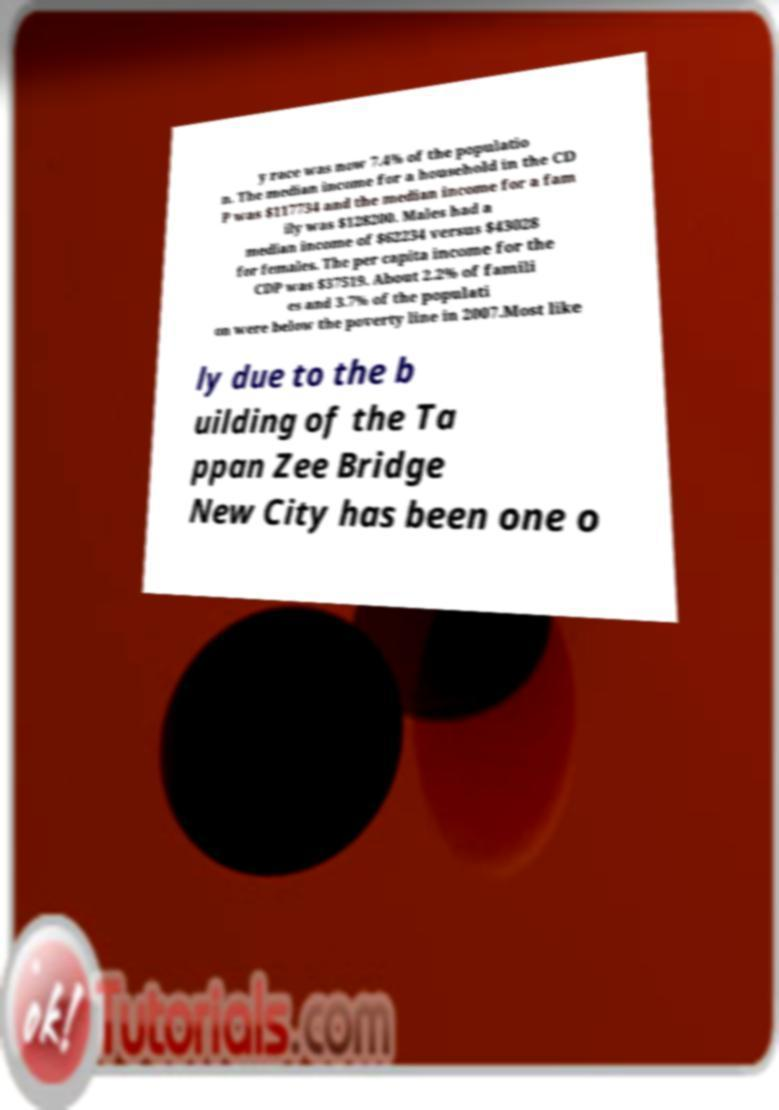Please identify and transcribe the text found in this image. y race was now 7.4% of the populatio n. The median income for a household in the CD P was $117734 and the median income for a fam ily was $128200. Males had a median income of $62234 versus $43028 for females. The per capita income for the CDP was $37519. About 2.2% of famili es and 3.7% of the populati on were below the poverty line in 2007.Most like ly due to the b uilding of the Ta ppan Zee Bridge New City has been one o 